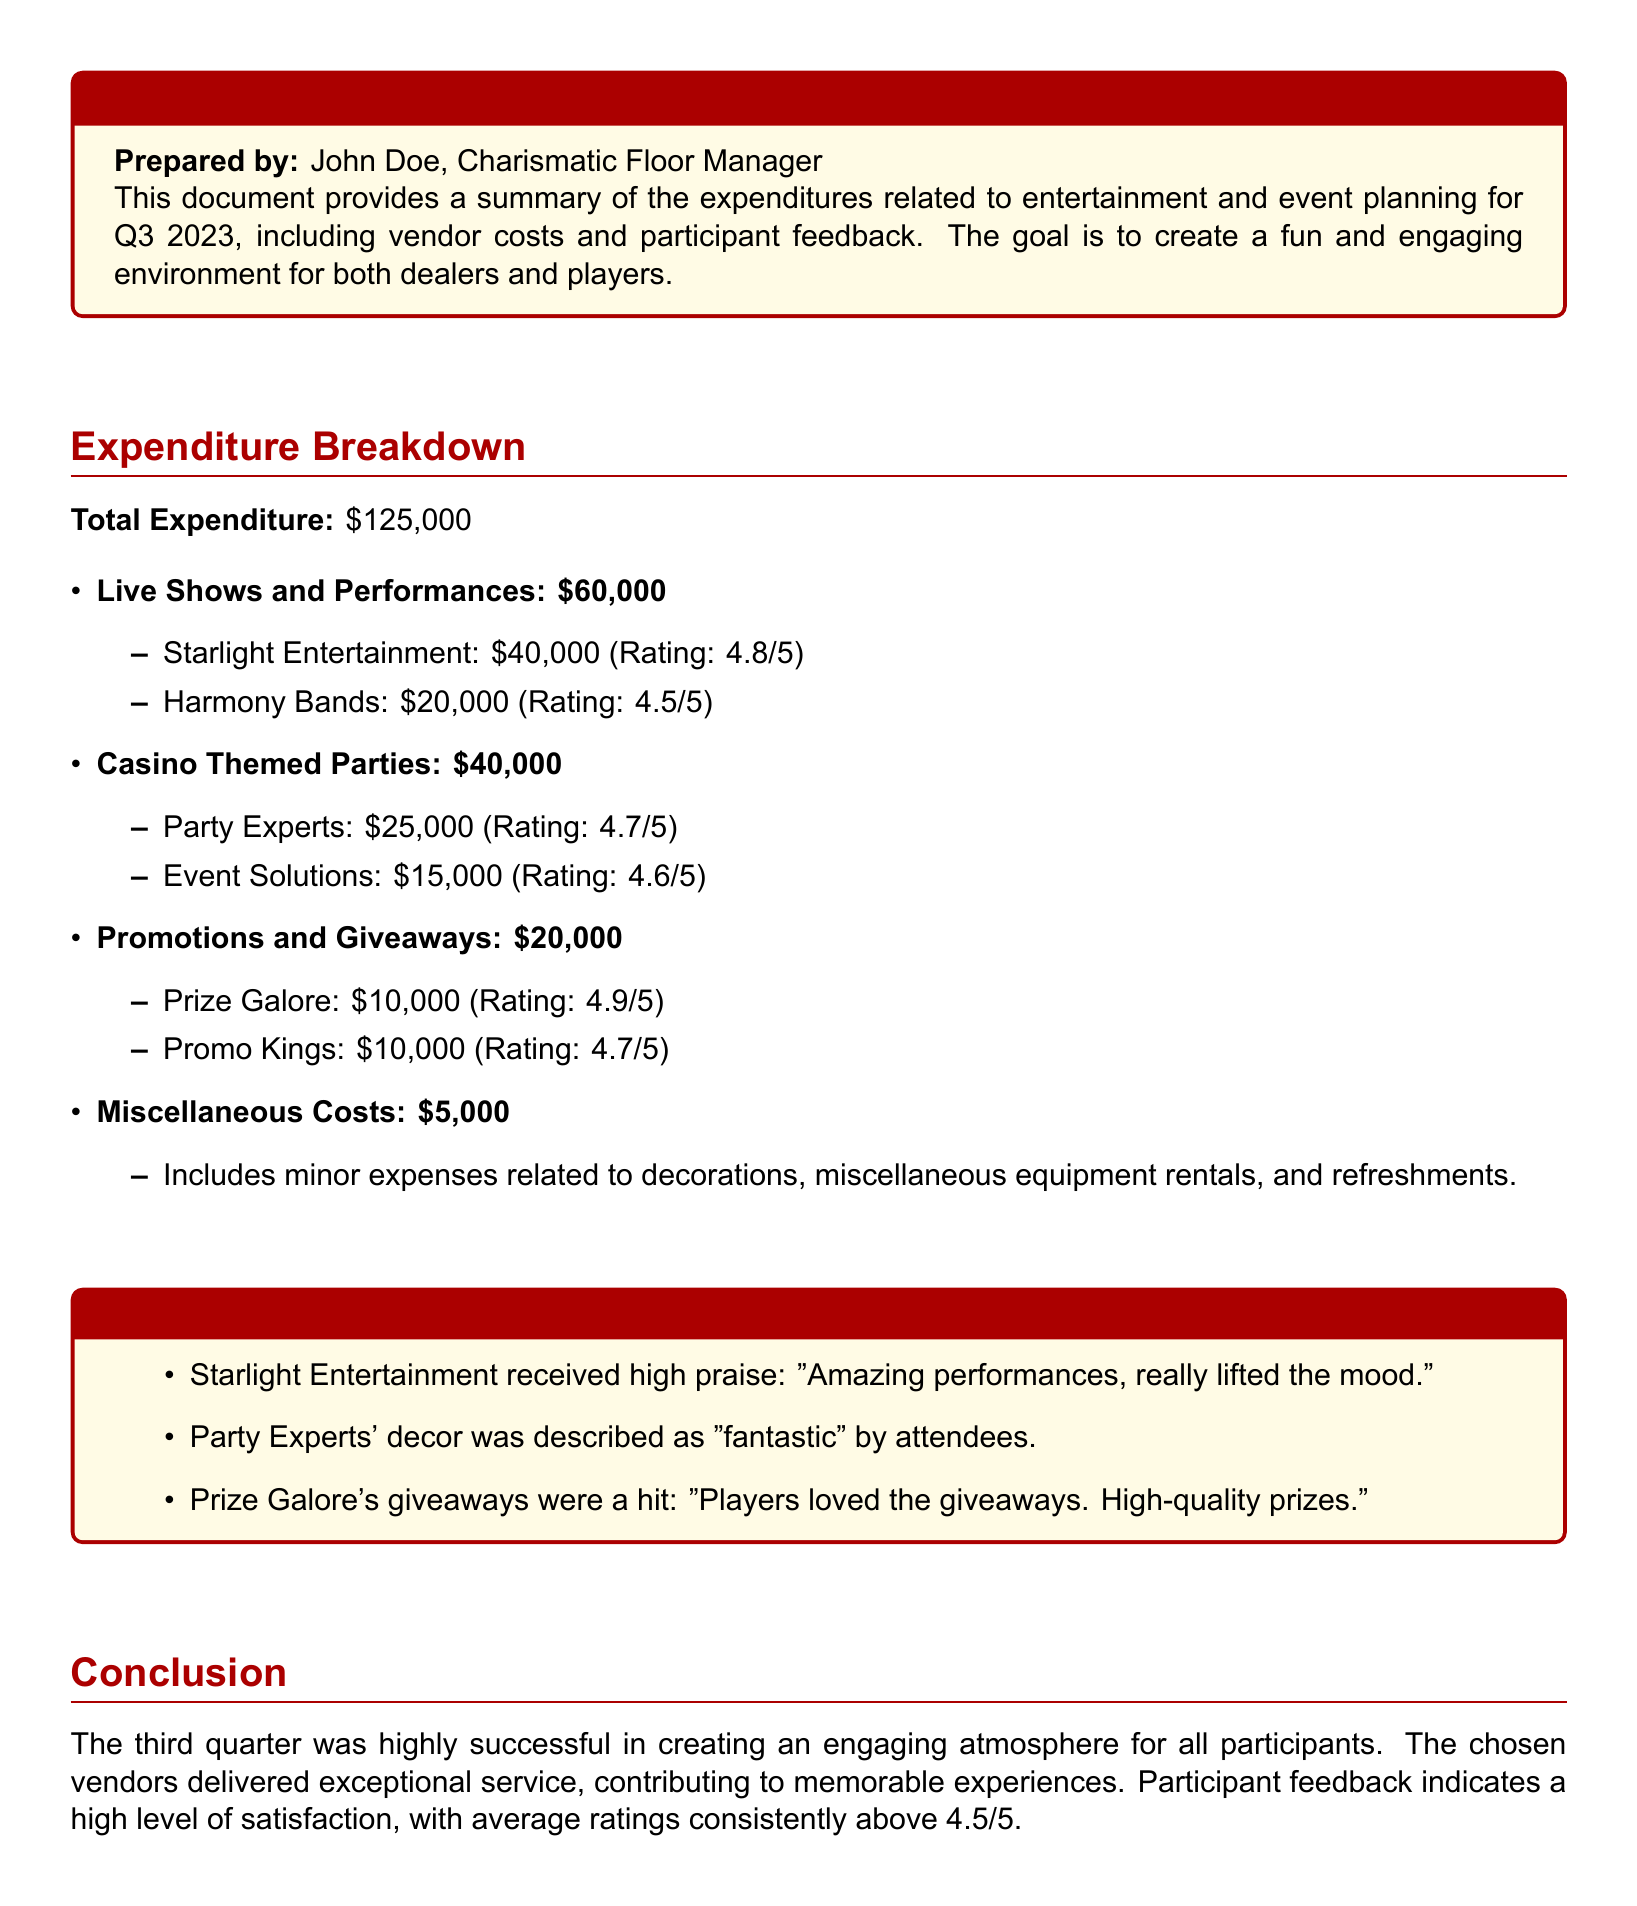What is the total expenditure? The total expenditure is explicitly stated in the document, which is $125,000.
Answer: $125,000 Who performed for $40,000? The document lists Starlight Entertainment as the vendor that received $40,000.
Answer: Starlight Entertainment What was the rating for Harmony Bands? The document specifies a rating of 4.5 out of 5 for Harmony Bands.
Answer: 4.5/5 What was the expenditure for Casino Themed Parties? The document details the expenditure for Casino Themed Parties as $40,000.
Answer: $40,000 Which vendor had the highest rating for promotions? According to the document, Prize Galore has the highest rating for promotions at 4.9 out of 5.
Answer: Prize Galore How much was spent on miscellaneous costs? The miscellaneous costs listed in the document amount to $5,000.
Answer: $5,000 What did attendees describe Party Experts' decor as? The document quotes attendees describing Party Experts' decor as "fantastic."
Answer: "fantastic" What was the focus of the report? The document explicitly states that the focus is on quarterly entertainment and event planning expenditures.
Answer: Quarterly entertainment and event planning expenditures What is the average rating for the vendors? The document indicates that the average ratings are consistently above 4.5 out of 5.
Answer: above 4.5/5 